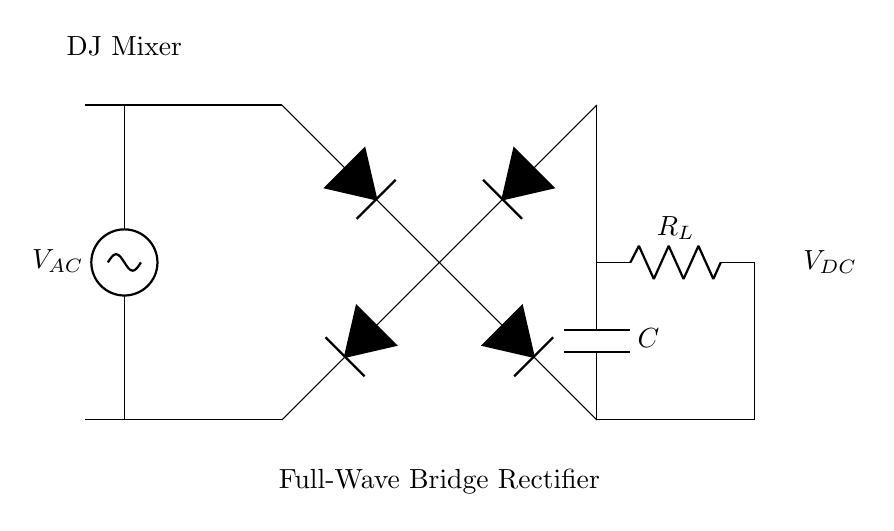What is the type of rectification shown in the diagram? The diagram depicts a full-wave rectification process, as indicated by the use of four diodes forming a bridge configuration that allows both halves of the AC signal to contribute to the output.
Answer: Full-wave What is the load component labeled in the circuit? The load component in the circuit is labeled as R_L, which stands for a resistor that is typically used to represent the load in a circuit for the purpose of converting electrical energy into heat or another form of energy.
Answer: R_L How many diodes are used in the bridge rectifier? In the bridge rectifier configuration depicted, four diodes are utilized to achieve rectification by allowing current to flow in both directions from the AC source, ensuring efficient conversion to DC.
Answer: Four What does the capacitor in the circuit do? The capacitor is used to smooth the output voltage by storing energy and releasing it as needed, effectively reducing fluctuations in the DC output voltage produced by the rectification process.
Answer: Smoothes voltage What type of signal is the input voltage labeled as in the diagram? The input voltage is labeled as V_AC, indicating that it is an alternating current signal, which is standard for signals coming from devices like a DJ mixer.
Answer: Alternating current What is the output voltage of the circuit labeled as? The output voltage from the bridge rectifier and load is labeled as V_DC, which signifies that it is the direct current voltage resultant from the rectification of the alternating input voltage.
Answer: V_DC 